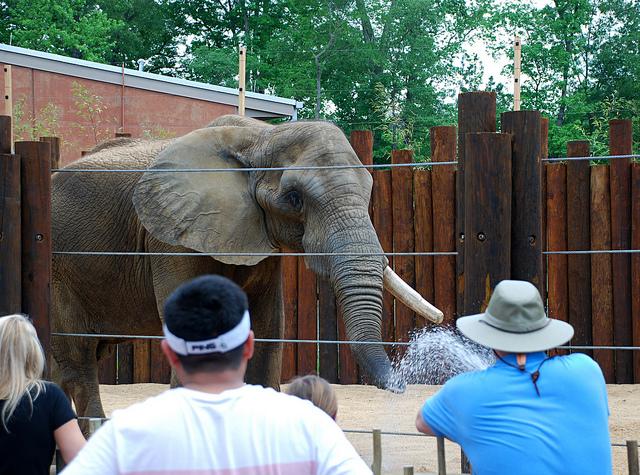How many tusks does the animal have?
Give a very brief answer. 1. What kind of animals are in the picture?
Give a very brief answer. Elephant. Is this animal in a zoo?
Concise answer only. Yes. 